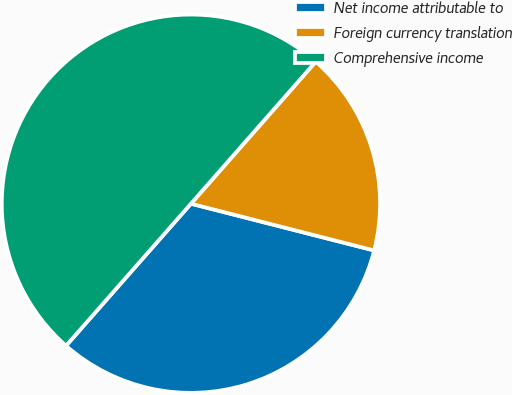Convert chart. <chart><loc_0><loc_0><loc_500><loc_500><pie_chart><fcel>Net income attributable to<fcel>Foreign currency translation<fcel>Comprehensive income<nl><fcel>32.5%<fcel>17.5%<fcel>50.0%<nl></chart> 